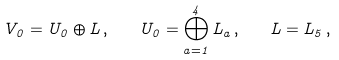<formula> <loc_0><loc_0><loc_500><loc_500>V _ { 0 } = U _ { 0 } \oplus L \, , \quad U _ { 0 } = \bigoplus _ { a = 1 } ^ { 4 } L _ { a } \, , \quad L = L _ { 5 } \, ,</formula> 